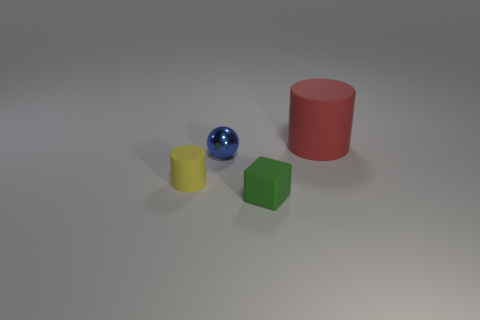How many brown objects are either big objects or tiny metal spheres?
Make the answer very short. 0. There is a large object that is behind the ball; is it the same color as the ball?
Your answer should be compact. No. What size is the thing in front of the rubber cylinder in front of the big matte thing?
Give a very brief answer. Small. What material is the yellow object that is the same size as the block?
Offer a terse response. Rubber. How many other objects are there of the same size as the yellow thing?
Your answer should be compact. 2. What number of blocks are yellow objects or big red matte things?
Give a very brief answer. 0. Are there any other things that have the same material as the tiny yellow cylinder?
Keep it short and to the point. Yes. What is the tiny object that is in front of the cylinder that is in front of the cylinder that is right of the small yellow object made of?
Provide a short and direct response. Rubber. What number of small spheres have the same material as the green cube?
Offer a terse response. 0. There is a green thing in front of the ball; is it the same size as the red matte thing?
Provide a succinct answer. No. 